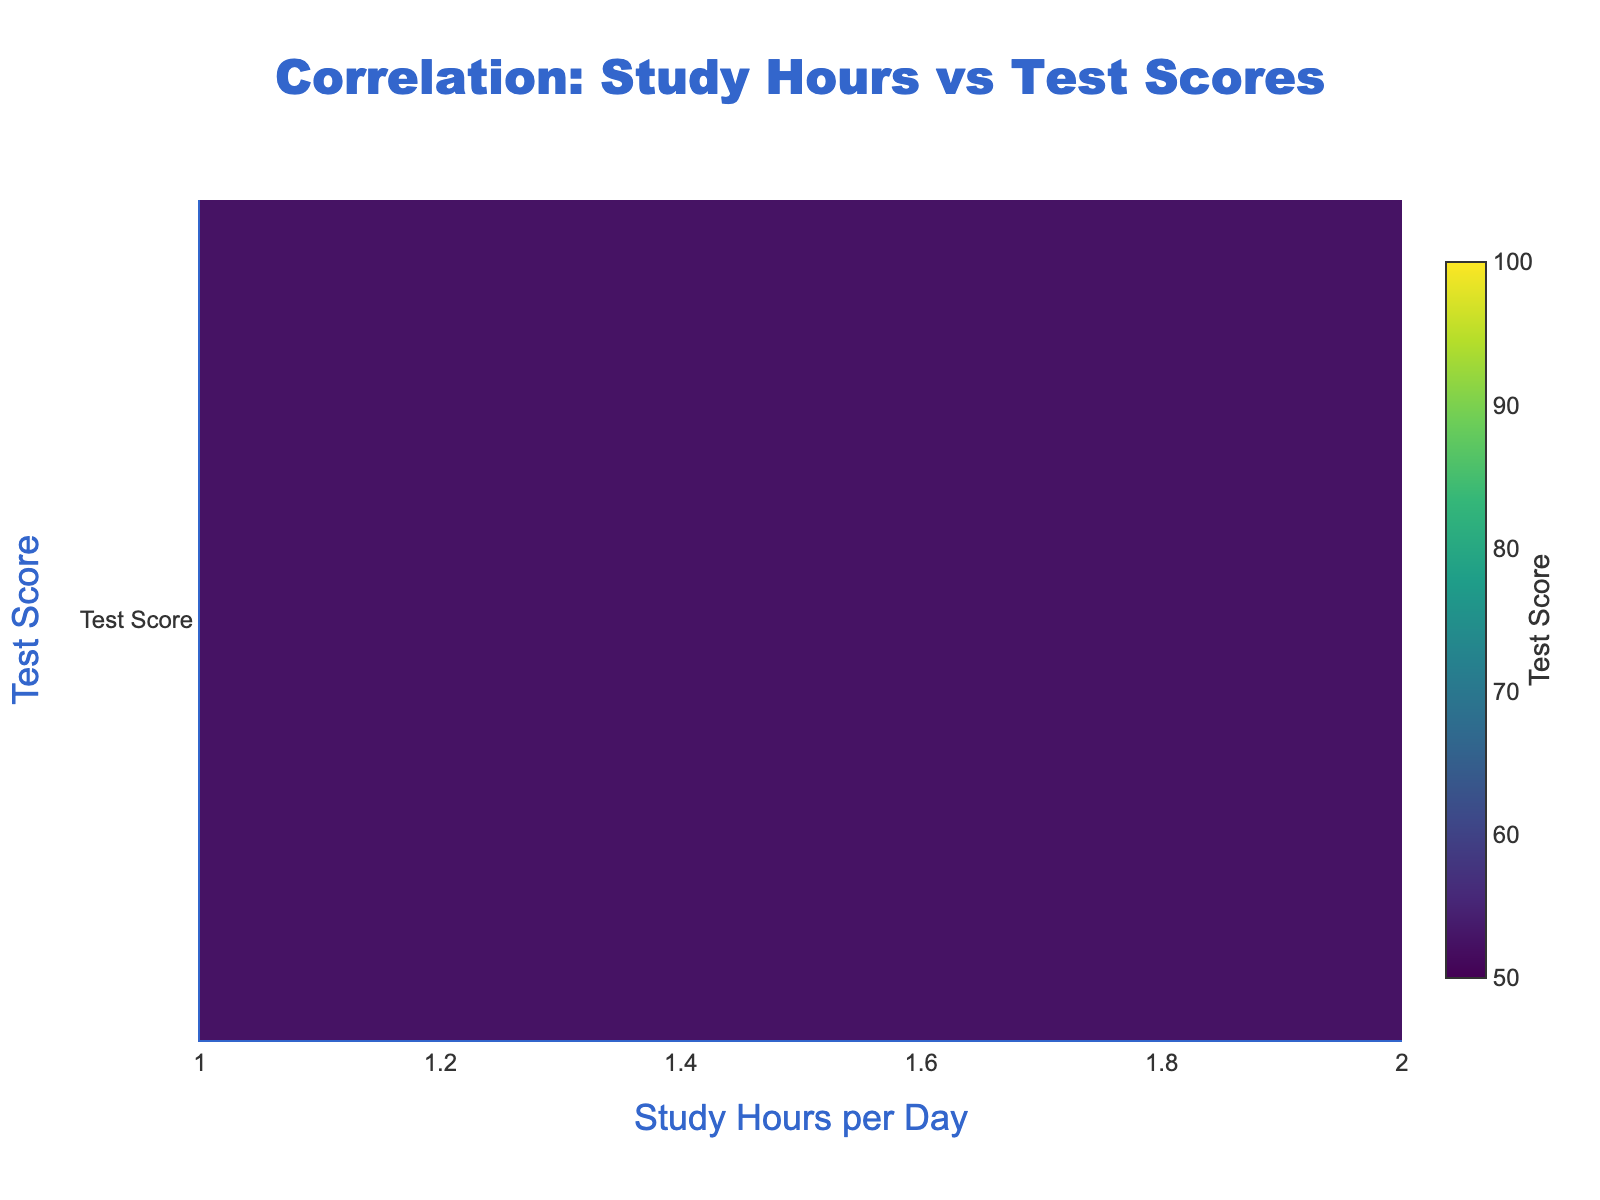What is the title of the heatmap? The title of the heatmap is located at the top and describes the main focus of the visualization. In this case, the title indicates that the heatmap shows the correlation between study hours and test scores.
Answer: Correlation: Study Hours vs Test Scores What are the variables represented on the axes of the heatmap? The x-axis represents the number of study hours per day, and the y-axis represents the test scores. These labels help us understand what the values on each axis signify.
Answer: Study Hours per Day, Test Score What is the color scale used in the heatmap? The color scale used in the heatmap is 'Viridis,' which ranges from dark to light greenish tones. Different shades represent different ranges of test scores.
Answer: Viridis What is the range of test scores in the heatmap? The range of test scores shown in the colorbar on the right side of the heatmap starts at 50 and goes up to 100. This means test scores in this range are being visualized.
Answer: 50 to 100 What is the general trend observed between study hours and test scores? Looking at the heatmap, we observe that as the number of study hours increases, the test scores also increase. This trend suggests a positive correlation between study hours and test scores.
Answer: Positive correlation What is the test score for students studying 4 hours per day? To find this, look at the cell corresponding to 4 study hours on the x-axis and check the color intensity and the colorbar. The test score is around 82.5.
Answer: Around 82.5 How does the test score for 6 study hours compare to that for 8 study hours? From the heatmap, we see that the color intensity for 6 and 8 study hours is very similar, indicating that the test scores are close. Checking the colorbar, both are in the range of 91 to 95.
Answer: Similar, both in the range 91 to 95 Which study hour results in the highest average test score? By examining the heatmap, we identify the brightest color, which corresponds to the highest scores. The highest average test scores are observed at 10 study hours per day.
Answer: 10 study hours per day Is there a noticeable change in test scores when increasing study hours from 3 to 5? By comparing the cells for 3, 4, and 5 study hours, we notice a progression from lighter to darker colors, showing an increase in test scores. Hence, increasing study hours from 3 to 5 leads to higher test scores.
Answer: Yes, there is an increase in test scores What is the color representation for the highest test scores, and what test scores do these colors correspond to? The highest test scores are represented by the brightest colors on the 'Viridis' scale. Checking the colorbar, these bright colors correspond to test scores in the range of 98 to 100.
Answer: Brightest colors, 98 to 100 